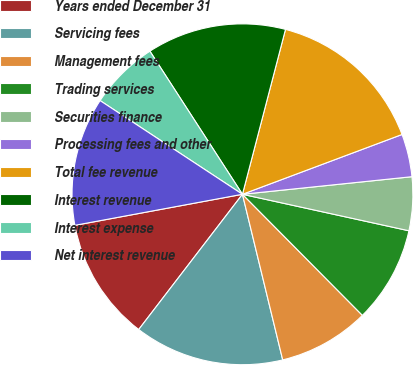Convert chart to OTSL. <chart><loc_0><loc_0><loc_500><loc_500><pie_chart><fcel>Years ended December 31<fcel>Servicing fees<fcel>Management fees<fcel>Trading services<fcel>Securities finance<fcel>Processing fees and other<fcel>Total fee revenue<fcel>Interest revenue<fcel>Interest expense<fcel>Net interest revenue<nl><fcel>11.67%<fcel>14.21%<fcel>8.63%<fcel>9.14%<fcel>5.08%<fcel>4.06%<fcel>15.23%<fcel>13.2%<fcel>6.6%<fcel>12.18%<nl></chart> 